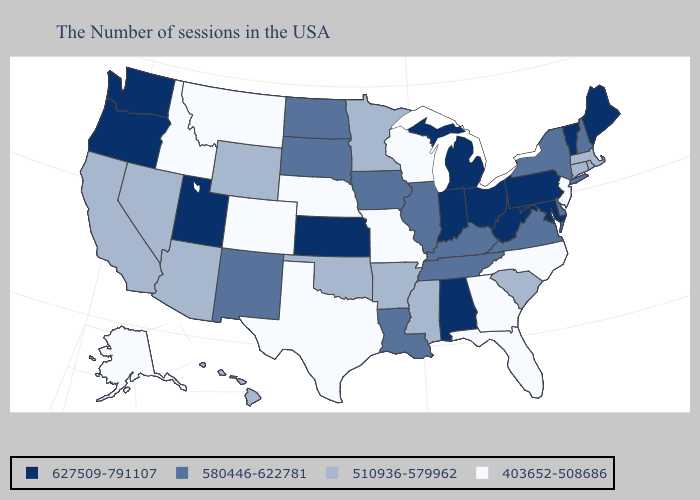What is the value of Kentucky?
Answer briefly. 580446-622781. Name the states that have a value in the range 627509-791107?
Be succinct. Maine, Vermont, Maryland, Pennsylvania, West Virginia, Ohio, Michigan, Indiana, Alabama, Kansas, Utah, Washington, Oregon. Does Utah have the highest value in the USA?
Be succinct. Yes. Name the states that have a value in the range 403652-508686?
Short answer required. New Jersey, North Carolina, Florida, Georgia, Wisconsin, Missouri, Nebraska, Texas, Colorado, Montana, Idaho, Alaska. Does Montana have the lowest value in the USA?
Quick response, please. Yes. Name the states that have a value in the range 580446-622781?
Be succinct. New Hampshire, New York, Delaware, Virginia, Kentucky, Tennessee, Illinois, Louisiana, Iowa, South Dakota, North Dakota, New Mexico. What is the value of Washington?
Keep it brief. 627509-791107. What is the value of Rhode Island?
Keep it brief. 510936-579962. Is the legend a continuous bar?
Write a very short answer. No. What is the highest value in the West ?
Concise answer only. 627509-791107. Name the states that have a value in the range 580446-622781?
Short answer required. New Hampshire, New York, Delaware, Virginia, Kentucky, Tennessee, Illinois, Louisiana, Iowa, South Dakota, North Dakota, New Mexico. Among the states that border New Jersey , does Pennsylvania have the highest value?
Be succinct. Yes. Name the states that have a value in the range 403652-508686?
Answer briefly. New Jersey, North Carolina, Florida, Georgia, Wisconsin, Missouri, Nebraska, Texas, Colorado, Montana, Idaho, Alaska. Does Oklahoma have a higher value than Hawaii?
Keep it brief. No. What is the value of Ohio?
Short answer required. 627509-791107. 